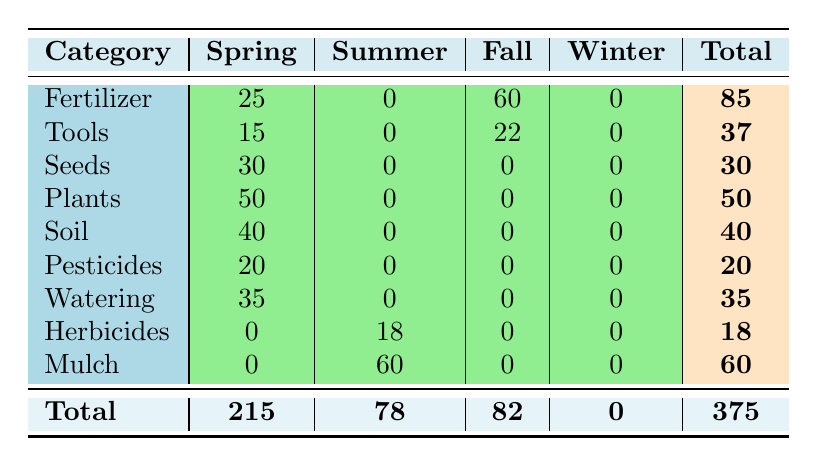What is the total quantity of products sold in Spring? To find the total quantity sold in Spring, we need to sum the quantities of all the categories listed under the Spring column. Adding them up gives us: 25 (Fertilizer) + 15 (Tools) + 30 (Seeds) + 50 (Plants) + 40 (Soil) + 20 (Pesticides) + 35 (Watering) + 0 (Herbicides) + 0 (Mulch) = 215.
Answer: 215 Which category had the highest sales in the summer? In the Summer column, we see that the only category with sales is Mulch, with a quantity of 60. All other categories have 0 sales. Thus, Mulch has the highest sales in summer.
Answer: Mulch Did any products have sales in winter? Looking at the Winter column, we can see that all categories have 0 sales. Therefore, no products had sales in winter.
Answer: No What category saw the highest total quantity sold overall? We need to look at the Total column and compare the quantities. Fertilizer has 85, Tools has 37, Seeds has 30, Plants has 50, Soil has 40, Pesticides has 20, Watering has 35, Herbicides has 18, and Mulch has 60. The highest quantity is for Fertilizer with 85.
Answer: Fertilizer What is the average quantity sold for all categories that had sales in the fall? For the Fall column, only Fertilizer (60) and Tools (22) sold products. To find the average, we sum these two quantities (60 + 22 = 82) and divide by the number of categories with sales (which is 2), giving us an average of 82/2 = 41.
Answer: 41 What is the total quantity sold for Tools across all seasons? We look at the Total column for Tools, which shows a total of 37, made up of 15 in Spring and 22 in Fall. There are no sales in Summer and Winter. Thus, the total quantity sold for Tools is simply 37.
Answer: 37 How much more quantity of Watering products was sold compared to Herbicides? For Watering, 35 units were sold, and for Herbicides, 18 units were sold. To find the difference, we subtract the quantity of Herbicides from that of Watering: 35 - 18 = 17.
Answer: 17 Which two seasons had the most total quantity sold when combined? Adding the totals, we have Spring (215) and Summer (78) compared to Fall (82) and Winter (0). Adding Spring and Summer gives 215 + 78 = 293, while adding Fall and Winter gives only 82. Therefore, Spring and Summer combined had the most sales.
Answer: Spring and Summer 